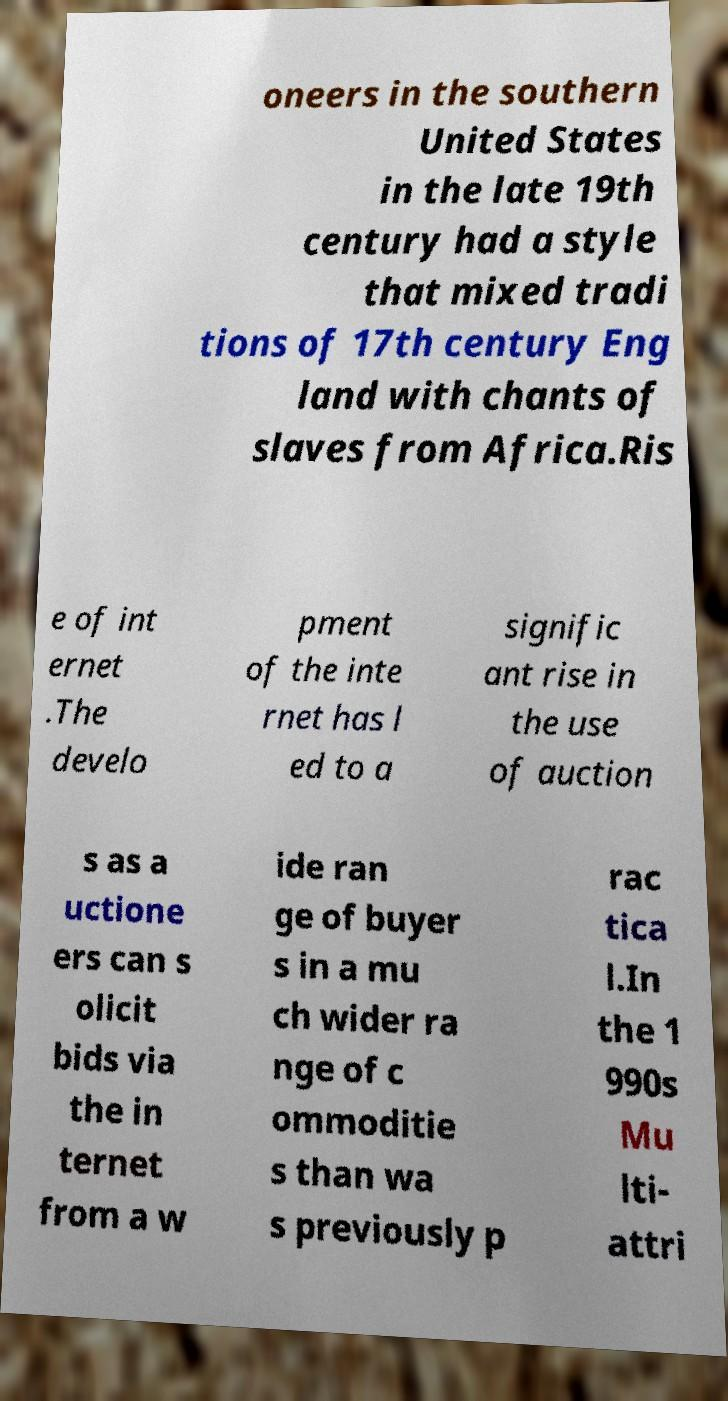I need the written content from this picture converted into text. Can you do that? oneers in the southern United States in the late 19th century had a style that mixed tradi tions of 17th century Eng land with chants of slaves from Africa.Ris e of int ernet .The develo pment of the inte rnet has l ed to a signific ant rise in the use of auction s as a uctione ers can s olicit bids via the in ternet from a w ide ran ge of buyer s in a mu ch wider ra nge of c ommoditie s than wa s previously p rac tica l.In the 1 990s Mu lti- attri 